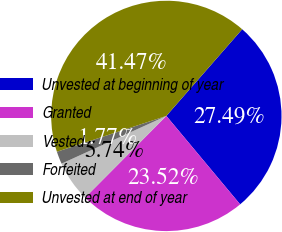<chart> <loc_0><loc_0><loc_500><loc_500><pie_chart><fcel>Unvested at beginning of year<fcel>Granted<fcel>Vested<fcel>Forfeited<fcel>Unvested at end of year<nl><fcel>27.49%<fcel>23.52%<fcel>5.74%<fcel>1.77%<fcel>41.47%<nl></chart> 